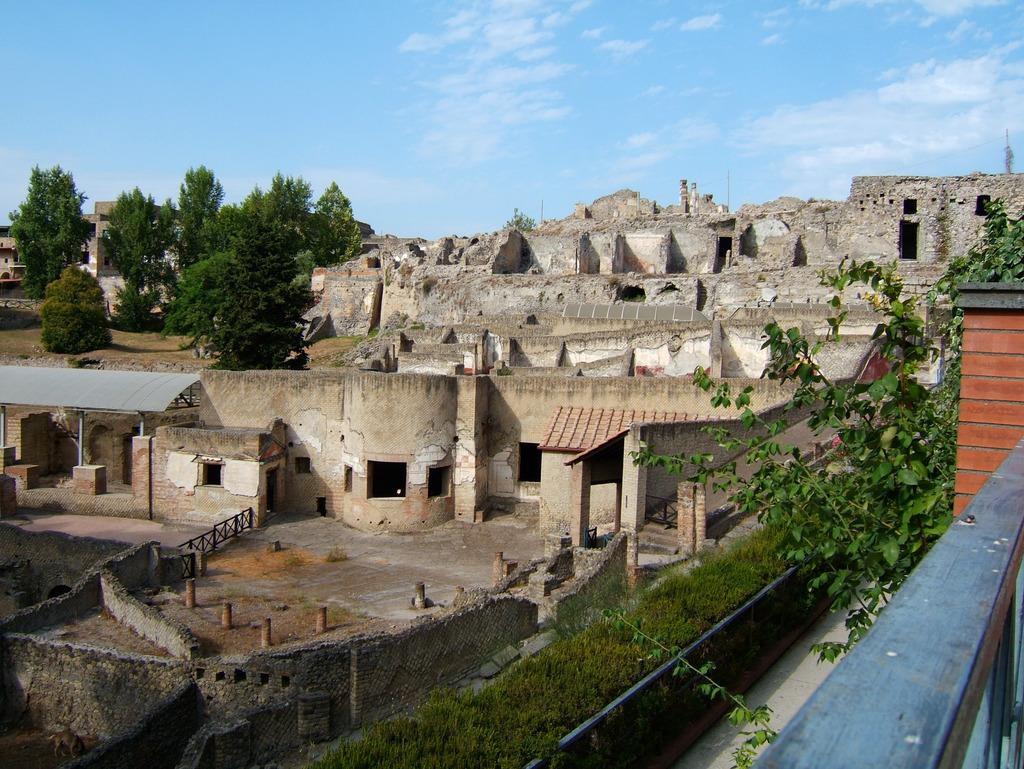What type of structure can be seen in the image? There is a monument in the image. What type of residential building is present in the image? There is a house with a roof in the image. What type of vegetation is present in the image? Trees and plants are present in the image. What type of architectural structure can be seen in the image? There is a building and a tower in the image. What type of ground cover is visible in the image? Grass is visible in the image. What type of barrier is present in the image? There is a fence in the image. What is the condition of the sky in the image? The sky is visible in the image and appears cloudy. What type of pain can be seen on the faces of the dinosaurs in the image? There are no dinosaurs present in the image, so there is no pain to observe on their faces. What type of loss is depicted in the image? There is no loss depicted in the image; it features a monument, a house, trees, a building, a tower, grass, a fence, plants, and a cloudy sky. 